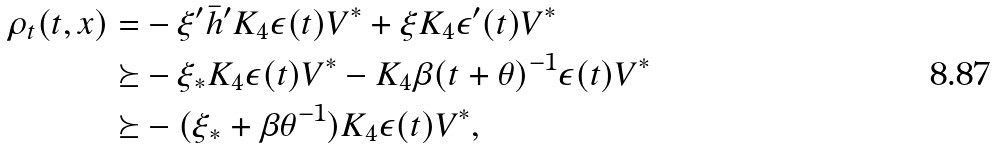<formula> <loc_0><loc_0><loc_500><loc_500>\rho _ { t } ( t , x ) = & - \xi ^ { \prime } \bar { h } ^ { \prime } K _ { 4 } \epsilon ( t ) V ^ { * } + \xi K _ { 4 } \epsilon ^ { \prime } ( t ) V ^ { * } \\ \succeq & - \xi _ { * } K _ { 4 } \epsilon ( t ) V ^ { * } - K _ { 4 } \beta ( t + \theta ) ^ { - 1 } \epsilon ( t ) V ^ { * } \\ \succeq & - ( \xi _ { * } + \beta \theta ^ { - 1 } ) K _ { 4 } \epsilon ( t ) V ^ { * } ,</formula> 